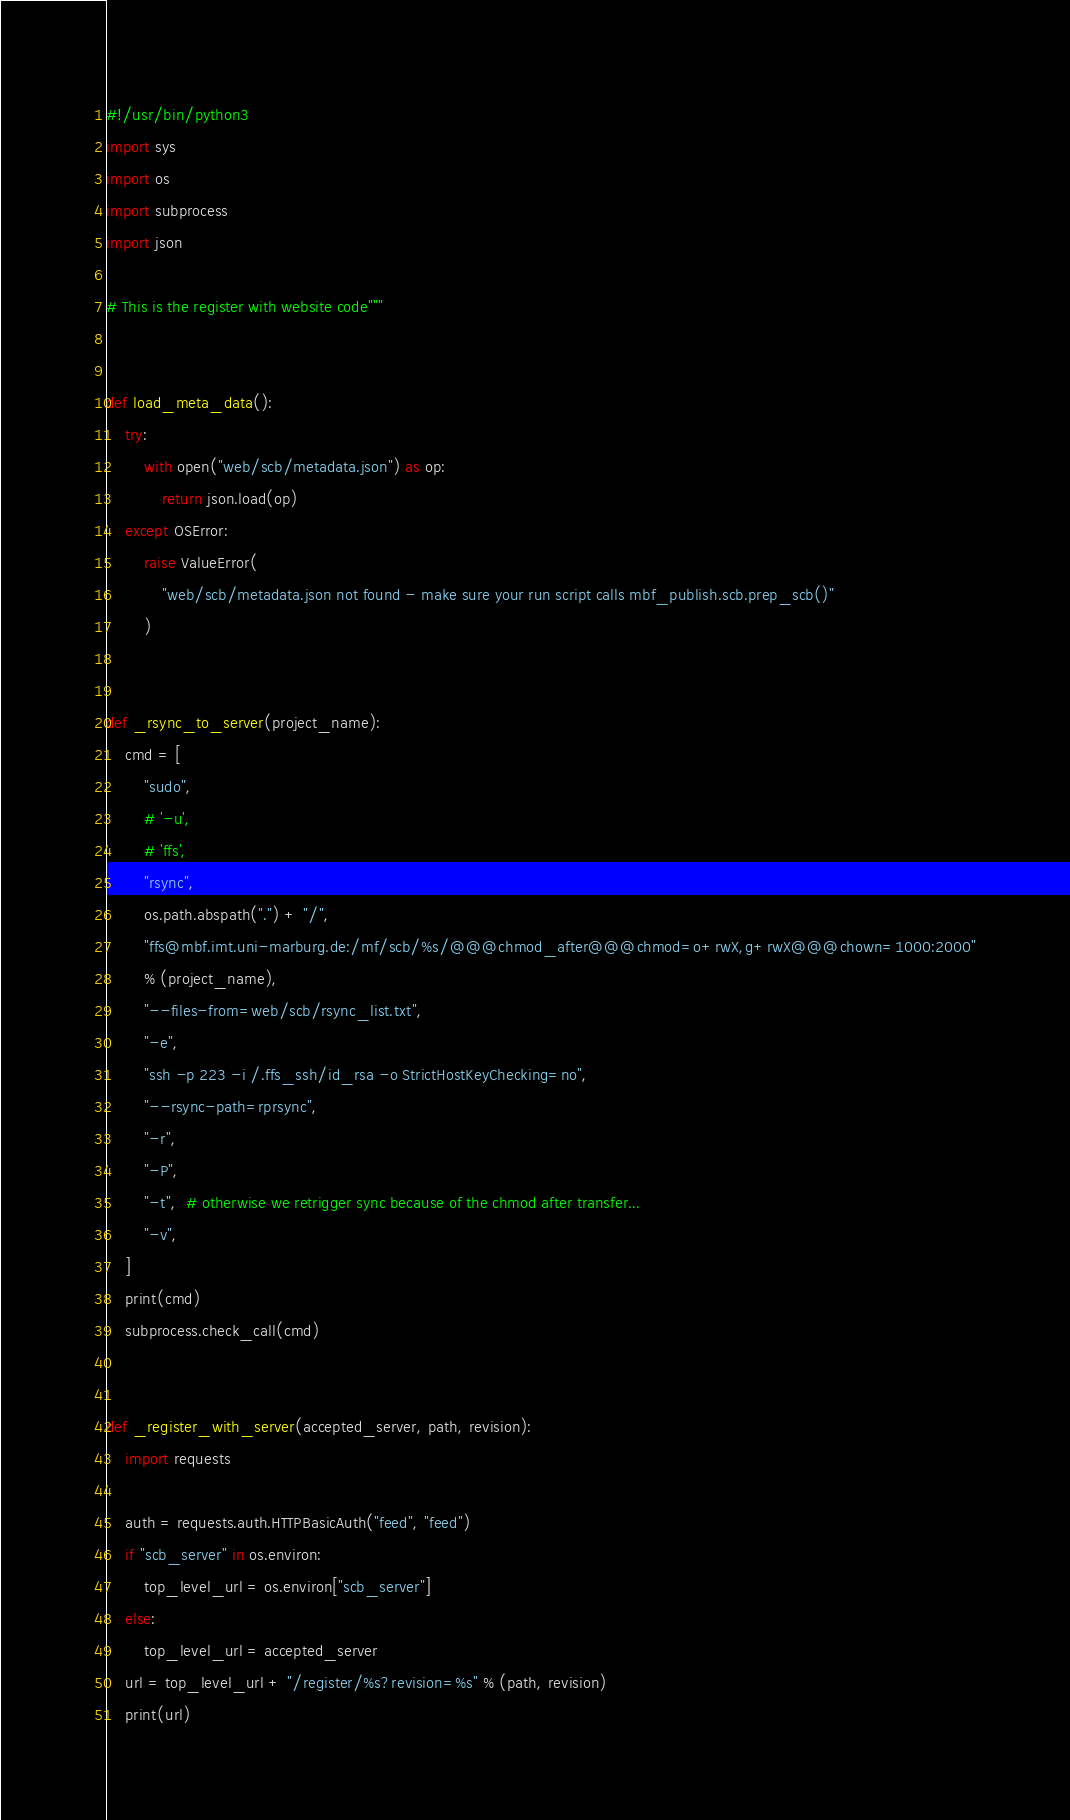<code> <loc_0><loc_0><loc_500><loc_500><_Python_>#!/usr/bin/python3
import sys
import os
import subprocess
import json

# This is the register with website code"""


def load_meta_data():
    try:
        with open("web/scb/metadata.json") as op:
            return json.load(op)
    except OSError:
        raise ValueError(
            "web/scb/metadata.json not found - make sure your run script calls mbf_publish.scb.prep_scb()"
        )


def _rsync_to_server(project_name):
    cmd = [
        "sudo",
        # '-u',
        # 'ffs',
        "rsync",
        os.path.abspath(".") + "/",
        "ffs@mbf.imt.uni-marburg.de:/mf/scb/%s/@@@chmod_after@@@chmod=o+rwX,g+rwX@@@chown=1000:2000"
        % (project_name),
        "--files-from=web/scb/rsync_list.txt",
        "-e",
        "ssh -p 223 -i /.ffs_ssh/id_rsa -o StrictHostKeyChecking=no",
        "--rsync-path=rprsync",
        "-r",
        "-P",
        "-t",  # otherwise we retrigger sync because of the chmod after transfer...
        "-v",
    ]
    print(cmd)
    subprocess.check_call(cmd)


def _register_with_server(accepted_server, path, revision):
    import requests

    auth = requests.auth.HTTPBasicAuth("feed", "feed")
    if "scb_server" in os.environ:
        top_level_url = os.environ["scb_server"]
    else:
        top_level_url = accepted_server
    url = top_level_url + "/register/%s?revision=%s" % (path, revision)
    print(url)</code> 